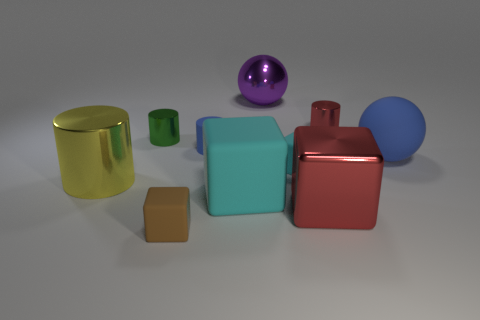Are there an equal number of small green objects in front of the large yellow cylinder and purple objects that are behind the small red metal cylinder?
Ensure brevity in your answer.  No. There is a tiny block that is behind the big metal thing that is in front of the yellow metal object; what number of tiny blue cylinders are left of it?
Provide a succinct answer. 1. What shape is the rubber object that is the same color as the large rubber cube?
Provide a succinct answer. Cube. Is the color of the tiny matte cylinder the same as the tiny metal thing to the left of the large purple metal thing?
Keep it short and to the point. No. Is the number of big matte things to the left of the tiny cyan thing greater than the number of cylinders?
Give a very brief answer. No. How many things are large matte things that are behind the small cyan cube or metal objects on the left side of the tiny green metal cylinder?
Offer a terse response. 2. What size is the green object that is the same material as the big red thing?
Give a very brief answer. Small. There is a small matte object to the right of the purple thing; is it the same shape as the yellow object?
Your answer should be very brief. No. The shiny object that is the same color as the shiny cube is what size?
Your answer should be very brief. Small. How many blue things are big spheres or cylinders?
Provide a short and direct response. 2. 